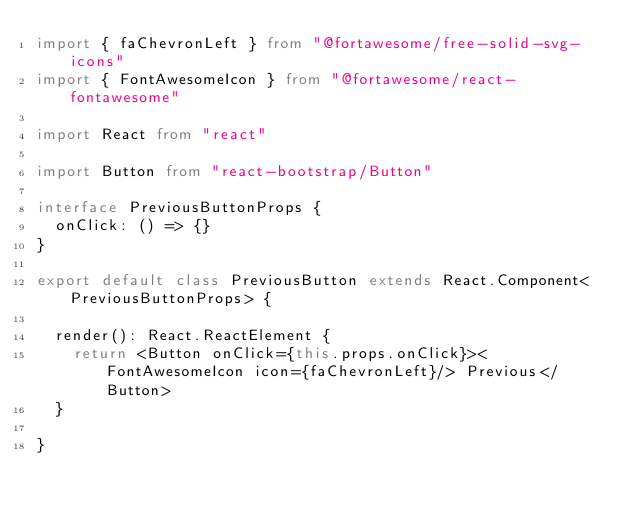<code> <loc_0><loc_0><loc_500><loc_500><_TypeScript_>import { faChevronLeft } from "@fortawesome/free-solid-svg-icons"
import { FontAwesomeIcon } from "@fortawesome/react-fontawesome"

import React from "react"

import Button from "react-bootstrap/Button"

interface PreviousButtonProps {
  onClick: () => {}
}

export default class PreviousButton extends React.Component<PreviousButtonProps> {

  render(): React.ReactElement {
    return <Button onClick={this.props.onClick}><FontAwesomeIcon icon={faChevronLeft}/> Previous</Button>
  }

}
</code> 